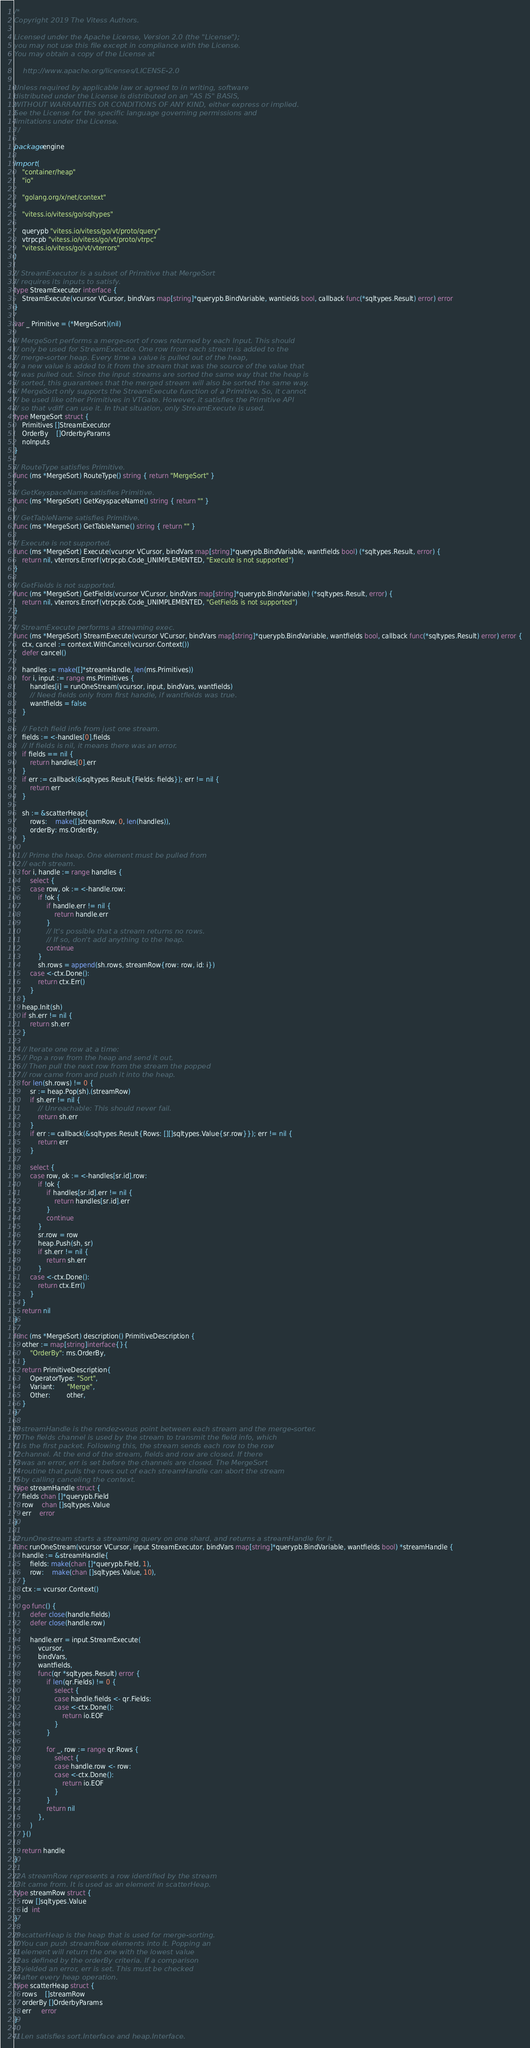Convert code to text. <code><loc_0><loc_0><loc_500><loc_500><_Go_>/*
Copyright 2019 The Vitess Authors.

Licensed under the Apache License, Version 2.0 (the "License");
you may not use this file except in compliance with the License.
You may obtain a copy of the License at

    http://www.apache.org/licenses/LICENSE-2.0

Unless required by applicable law or agreed to in writing, software
distributed under the License is distributed on an "AS IS" BASIS,
WITHOUT WARRANTIES OR CONDITIONS OF ANY KIND, either express or implied.
See the License for the specific language governing permissions and
limitations under the License.
*/

package engine

import (
	"container/heap"
	"io"

	"golang.org/x/net/context"

	"vitess.io/vitess/go/sqltypes"

	querypb "vitess.io/vitess/go/vt/proto/query"
	vtrpcpb "vitess.io/vitess/go/vt/proto/vtrpc"
	"vitess.io/vitess/go/vt/vterrors"
)

// StreamExecutor is a subset of Primitive that MergeSort
// requires its inputs to satisfy.
type StreamExecutor interface {
	StreamExecute(vcursor VCursor, bindVars map[string]*querypb.BindVariable, wantields bool, callback func(*sqltypes.Result) error) error
}

var _ Primitive = (*MergeSort)(nil)

// MergeSort performs a merge-sort of rows returned by each Input. This should
// only be used for StreamExecute. One row from each stream is added to the
// merge-sorter heap. Every time a value is pulled out of the heap,
// a new value is added to it from the stream that was the source of the value that
// was pulled out. Since the input streams are sorted the same way that the heap is
// sorted, this guarantees that the merged stream will also be sorted the same way.
// MergeSort only supports the StreamExecute function of a Primitive. So, it cannot
// be used like other Primitives in VTGate. However, it satisfies the Primitive API
// so that vdiff can use it. In that situation, only StreamExecute is used.
type MergeSort struct {
	Primitives []StreamExecutor
	OrderBy    []OrderbyParams
	noInputs
}

// RouteType satisfies Primitive.
func (ms *MergeSort) RouteType() string { return "MergeSort" }

// GetKeyspaceName satisfies Primitive.
func (ms *MergeSort) GetKeyspaceName() string { return "" }

// GetTableName satisfies Primitive.
func (ms *MergeSort) GetTableName() string { return "" }

// Execute is not supported.
func (ms *MergeSort) Execute(vcursor VCursor, bindVars map[string]*querypb.BindVariable, wantfields bool) (*sqltypes.Result, error) {
	return nil, vterrors.Errorf(vtrpcpb.Code_UNIMPLEMENTED, "Execute is not supported")
}

// GetFields is not supported.
func (ms *MergeSort) GetFields(vcursor VCursor, bindVars map[string]*querypb.BindVariable) (*sqltypes.Result, error) {
	return nil, vterrors.Errorf(vtrpcpb.Code_UNIMPLEMENTED, "GetFields is not supported")
}

// StreamExecute performs a streaming exec.
func (ms *MergeSort) StreamExecute(vcursor VCursor, bindVars map[string]*querypb.BindVariable, wantfields bool, callback func(*sqltypes.Result) error) error {
	ctx, cancel := context.WithCancel(vcursor.Context())
	defer cancel()

	handles := make([]*streamHandle, len(ms.Primitives))
	for i, input := range ms.Primitives {
		handles[i] = runOneStream(vcursor, input, bindVars, wantfields)
		// Need fields only from first handle, if wantfields was true.
		wantfields = false
	}

	// Fetch field info from just one stream.
	fields := <-handles[0].fields
	// If fields is nil, it means there was an error.
	if fields == nil {
		return handles[0].err
	}
	if err := callback(&sqltypes.Result{Fields: fields}); err != nil {
		return err
	}

	sh := &scatterHeap{
		rows:    make([]streamRow, 0, len(handles)),
		orderBy: ms.OrderBy,
	}

	// Prime the heap. One element must be pulled from
	// each stream.
	for i, handle := range handles {
		select {
		case row, ok := <-handle.row:
			if !ok {
				if handle.err != nil {
					return handle.err
				}
				// It's possible that a stream returns no rows.
				// If so, don't add anything to the heap.
				continue
			}
			sh.rows = append(sh.rows, streamRow{row: row, id: i})
		case <-ctx.Done():
			return ctx.Err()
		}
	}
	heap.Init(sh)
	if sh.err != nil {
		return sh.err
	}

	// Iterate one row at a time:
	// Pop a row from the heap and send it out.
	// Then pull the next row from the stream the popped
	// row came from and push it into the heap.
	for len(sh.rows) != 0 {
		sr := heap.Pop(sh).(streamRow)
		if sh.err != nil {
			// Unreachable: This should never fail.
			return sh.err
		}
		if err := callback(&sqltypes.Result{Rows: [][]sqltypes.Value{sr.row}}); err != nil {
			return err
		}

		select {
		case row, ok := <-handles[sr.id].row:
			if !ok {
				if handles[sr.id].err != nil {
					return handles[sr.id].err
				}
				continue
			}
			sr.row = row
			heap.Push(sh, sr)
			if sh.err != nil {
				return sh.err
			}
		case <-ctx.Done():
			return ctx.Err()
		}
	}
	return nil
}

func (ms *MergeSort) description() PrimitiveDescription {
	other := map[string]interface{}{
		"OrderBy": ms.OrderBy,
	}
	return PrimitiveDescription{
		OperatorType: "Sort",
		Variant:      "Merge",
		Other:        other,
	}
}

// streamHandle is the rendez-vous point between each stream and the merge-sorter.
// The fields channel is used by the stream to transmit the field info, which
// is the first packet. Following this, the stream sends each row to the row
// channel. At the end of the stream, fields and row are closed. If there
// was an error, err is set before the channels are closed. The MergeSort
// routine that pulls the rows out of each streamHandle can abort the stream
// by calling canceling the context.
type streamHandle struct {
	fields chan []*querypb.Field
	row    chan []sqltypes.Value
	err    error
}

// runOnestream starts a streaming query on one shard, and returns a streamHandle for it.
func runOneStream(vcursor VCursor, input StreamExecutor, bindVars map[string]*querypb.BindVariable, wantfields bool) *streamHandle {
	handle := &streamHandle{
		fields: make(chan []*querypb.Field, 1),
		row:    make(chan []sqltypes.Value, 10),
	}
	ctx := vcursor.Context()

	go func() {
		defer close(handle.fields)
		defer close(handle.row)

		handle.err = input.StreamExecute(
			vcursor,
			bindVars,
			wantfields,
			func(qr *sqltypes.Result) error {
				if len(qr.Fields) != 0 {
					select {
					case handle.fields <- qr.Fields:
					case <-ctx.Done():
						return io.EOF
					}
				}

				for _, row := range qr.Rows {
					select {
					case handle.row <- row:
					case <-ctx.Done():
						return io.EOF
					}
				}
				return nil
			},
		)
	}()

	return handle
}

// A streamRow represents a row identified by the stream
// it came from. It is used as an element in scatterHeap.
type streamRow struct {
	row []sqltypes.Value
	id  int
}

// scatterHeap is the heap that is used for merge-sorting.
// You can push streamRow elements into it. Popping an
// element will return the one with the lowest value
// as defined by the orderBy criteria. If a comparison
// yielded an error, err is set. This must be checked
// after every heap operation.
type scatterHeap struct {
	rows    []streamRow
	orderBy []OrderbyParams
	err     error
}

// Len satisfies sort.Interface and heap.Interface.</code> 